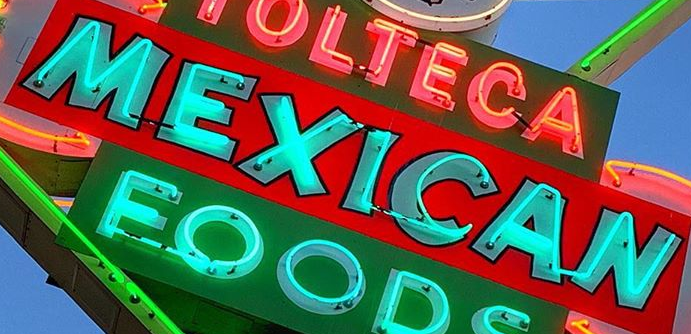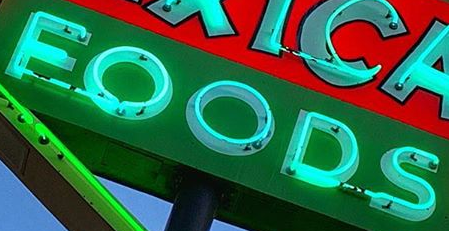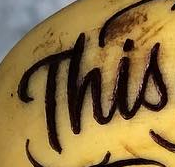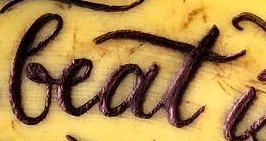What text appears in these images from left to right, separated by a semicolon? MEXICAN; FOODS; This; beat 